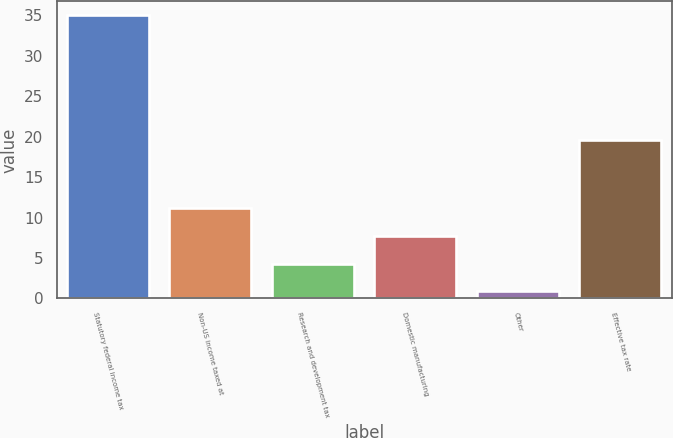Convert chart. <chart><loc_0><loc_0><loc_500><loc_500><bar_chart><fcel>Statutory federal income tax<fcel>Non-US income taxed at<fcel>Research and development tax<fcel>Domestic manufacturing<fcel>Other<fcel>Effective tax rate<nl><fcel>35<fcel>11.13<fcel>4.31<fcel>7.72<fcel>0.9<fcel>19.6<nl></chart> 